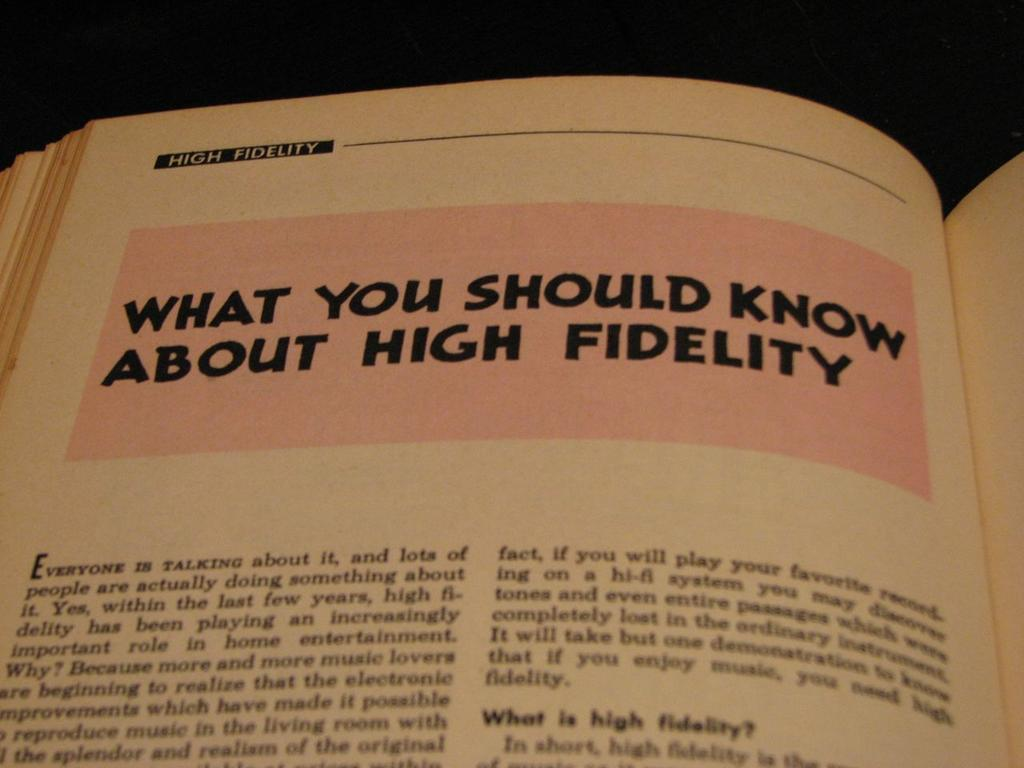<image>
Write a terse but informative summary of the picture. Book open on a page titled "What You Should Know About High Fidelity". 